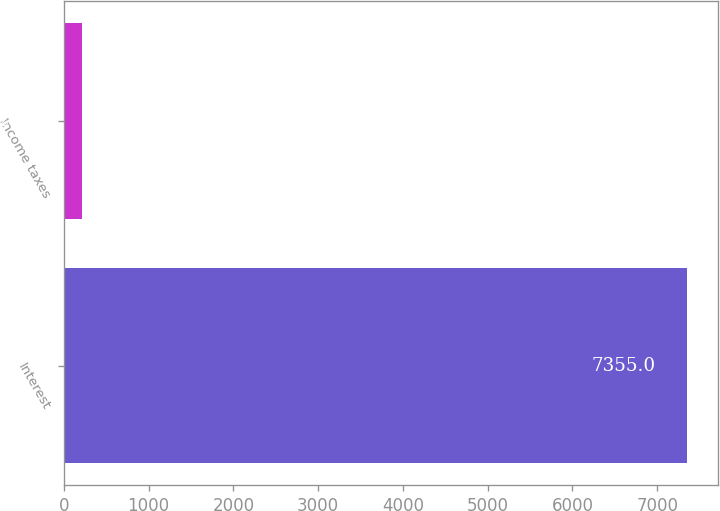Convert chart to OTSL. <chart><loc_0><loc_0><loc_500><loc_500><bar_chart><fcel>Interest<fcel>Income taxes<nl><fcel>7355<fcel>211<nl></chart> 